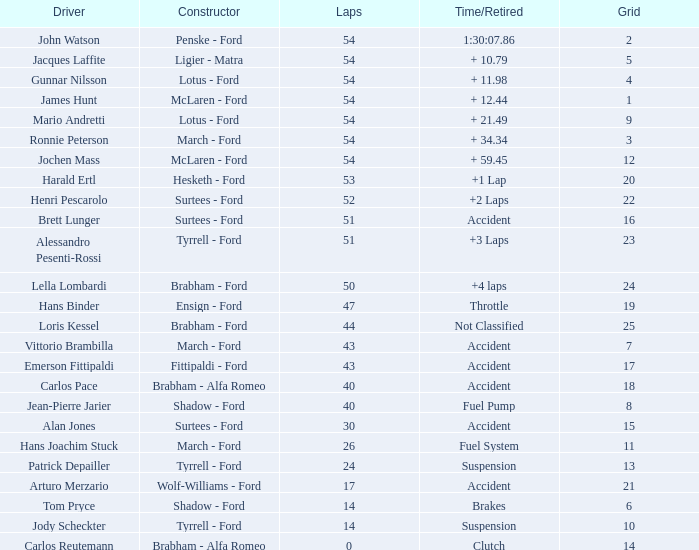How many circuits did emerson fittipaldi complete on a grid exceeding 14, and when was the time/retired of the incident? 1.0. 